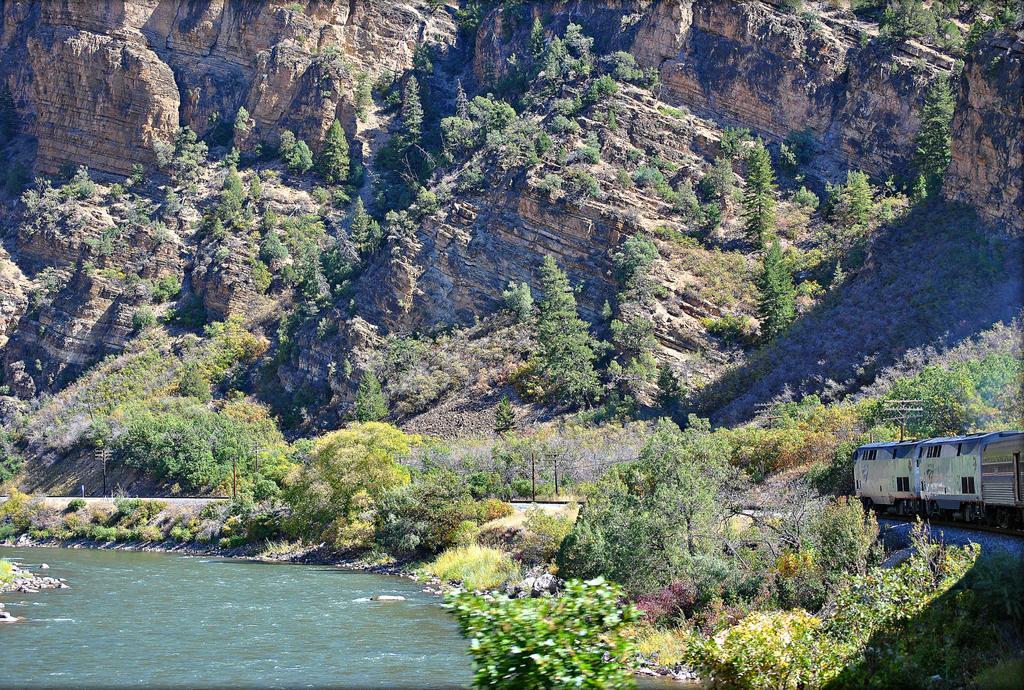How would you summarize this image in a sentence or two? As we can see in the image there is a hill and trees here and there. On the left there is water, on the right there is a train. 